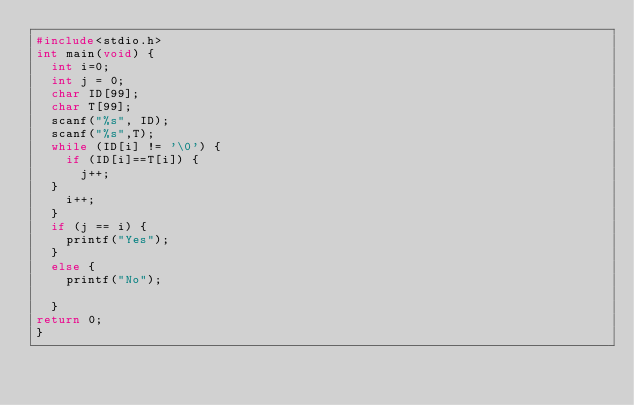Convert code to text. <code><loc_0><loc_0><loc_500><loc_500><_C_>#include<stdio.h>
int main(void) {
	int i=0;
	int j = 0;
	char ID[99];
	char T[99];
	scanf("%s", ID);
	scanf("%s",T);
	while (ID[i] != '\0') {
		if (ID[i]==T[i]) {
			j++;
	}
		i++;
	}
	if (j == i) {
		printf("Yes");
	}
	else {
		printf("No");

	}
return 0;
}</code> 